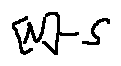<formula> <loc_0><loc_0><loc_500><loc_500>[ N ] - S</formula> 